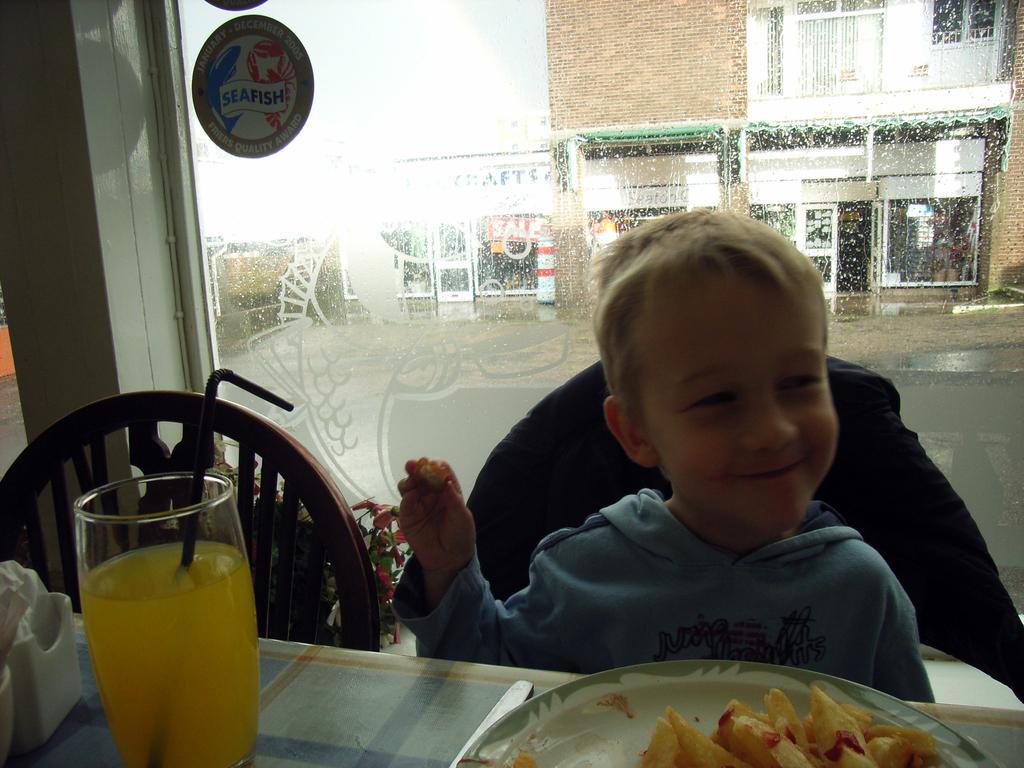Can you describe this image briefly? In this picture I can see a boy sitting on the chair in front of a table. On the table I can see glass, food items on plate and other objects. In the background I can see a glass wall and buildings. 